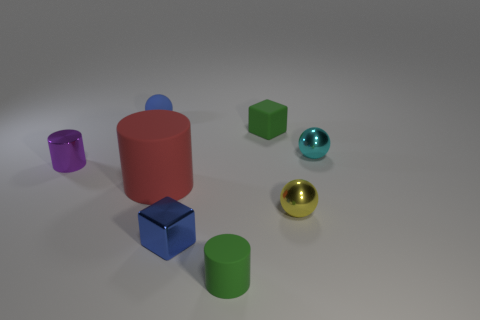Add 2 large cyan shiny balls. How many objects exist? 10 Subtract all balls. How many objects are left? 5 Add 5 purple metallic spheres. How many purple metallic spheres exist? 5 Subtract 1 green cubes. How many objects are left? 7 Subtract all tiny blue rubber cylinders. Subtract all blue balls. How many objects are left? 7 Add 7 yellow things. How many yellow things are left? 8 